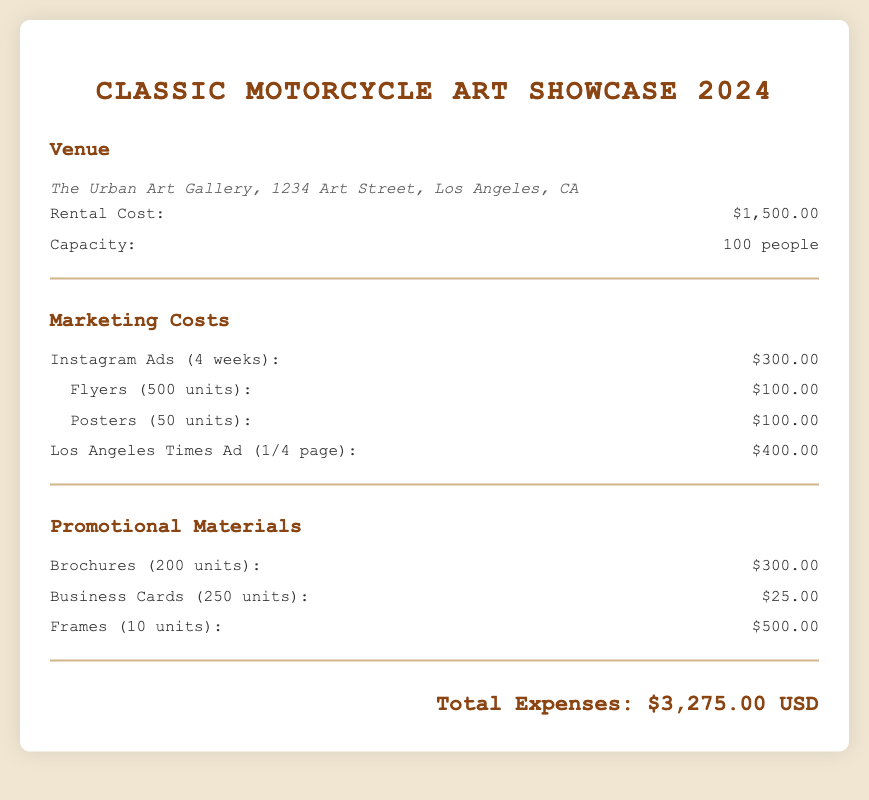what is the venue name? The venue name is clearly stated in the document as "The Urban Art Gallery."
Answer: The Urban Art Gallery what is the rental cost? The rental cost is specified as a monetary amount in the document.
Answer: $1,500.00 how many people can the venue accommodate? The document mentions the capacity of the venue directly.
Answer: 100 people what is the cost of Instagram Ads? The cost for Instagram Ads is listed as an expense in the marketing section.
Answer: $300.00 how many business cards are included in the promotional materials? The document provides details on the quantity of business cards in the promotional materials section.
Answer: 250 units what is the total expenses amount? The total expenses are calculated and presented at the end of the document.
Answer: $3,275.00 USD how many brochures were printed? The number of brochures is outlined in the promotional materials section of the document.
Answer: 200 units what is the cost of frames? The cost of frames is provided as part of the promotional materials expenses.
Answer: $500.00 what type of marketing materials include flyers? The document lists specific types of marketing materials, including flyers, found in the marketing costs section.
Answer: Flyers (500 units) 